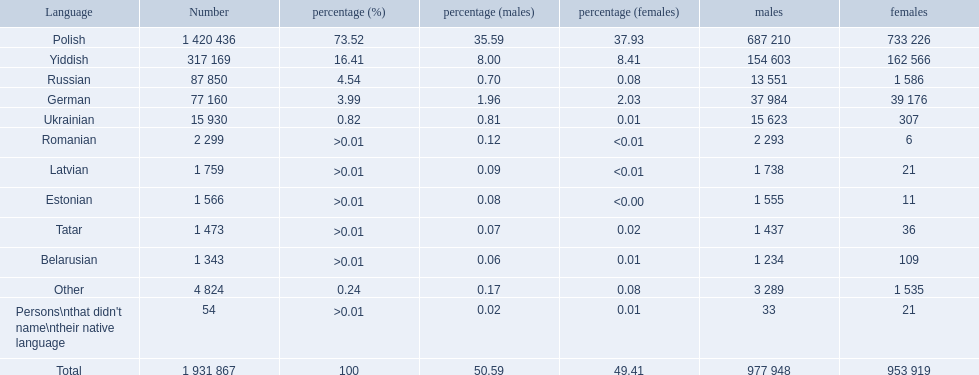Which languages had percentages of >0.01? Romanian, Latvian, Estonian, Tatar, Belarusian. What was the top language? Romanian. 